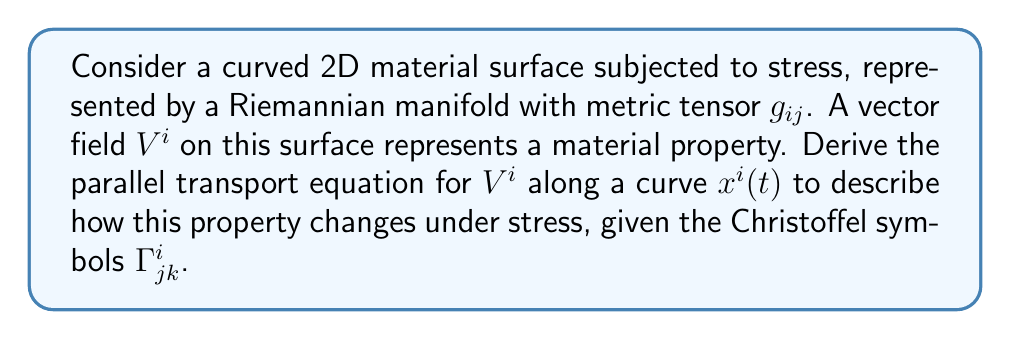What is the answer to this math problem? 1) In a curved space, parallel transport is described by the covariant derivative. For a vector field $V^i$, the covariant derivative along a curve $x^i(t)$ is given by:

   $$\frac{DV^i}{dt} = \frac{dV^i}{dt} + \Gamma^i_{jk}V^j\frac{dx^k}{dt}$$

2) The parallel transport equation states that this covariant derivative should vanish:

   $$\frac{DV^i}{dt} = 0$$

3) Substituting the expression for the covariant derivative:

   $$\frac{dV^i}{dt} + \Gamma^i_{jk}V^j\frac{dx^k}{dt} = 0$$

4) Rearranging the terms:

   $$\frac{dV^i}{dt} = -\Gamma^i_{jk}V^j\frac{dx^k}{dt}$$

5) This equation describes how the vector field $V^i$ (representing a material property) changes along the curve $x^i(t)$ (representing the deformation path under stress) in the curved space (stressed material surface).

6) The Christoffel symbols $\Gamma^i_{jk}$ encode the curvature of the space and are related to the metric tensor $g_{ij}$ by:

   $$\Gamma^i_{jk} = \frac{1}{2}g^{im}(\partial_j g_{km} + \partial_k g_{jm} - \partial_m g_{jk})$$

   where $g^{im}$ is the inverse metric tensor and $\partial_j$ denotes partial differentiation with respect to $x^j$.
Answer: $$\frac{dV^i}{dt} = -\Gamma^i_{jk}V^j\frac{dx^k}{dt}$$ 